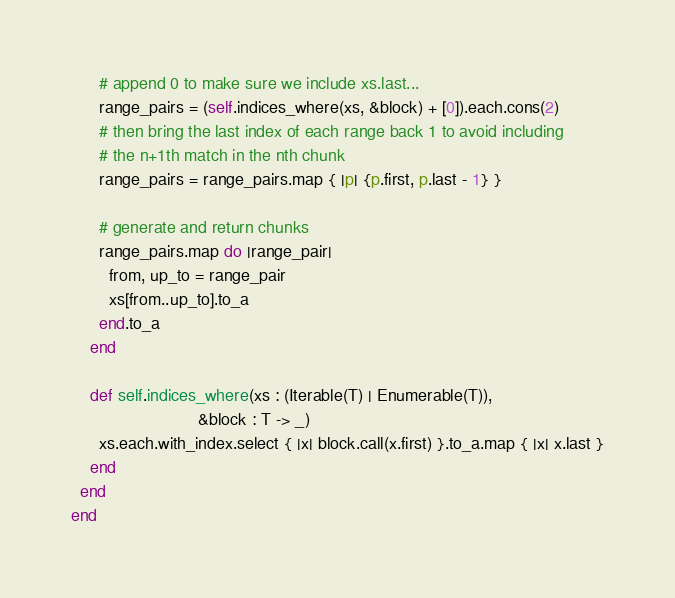Convert code to text. <code><loc_0><loc_0><loc_500><loc_500><_Crystal_>      # append 0 to make sure we include xs.last...
      range_pairs = (self.indices_where(xs, &block) + [0]).each.cons(2)
      # then bring the last index of each range back 1 to avoid including
      # the n+1th match in the nth chunk
      range_pairs = range_pairs.map { |p| {p.first, p.last - 1} }

      # generate and return chunks
      range_pairs.map do |range_pair|
        from, up_to = range_pair
        xs[from..up_to].to_a
      end.to_a
    end

    def self.indices_where(xs : (Iterable(T) | Enumerable(T)),
                           &block : T -> _)
      xs.each.with_index.select { |x| block.call(x.first) }.to_a.map { |x| x.last }
    end
  end
end

</code> 